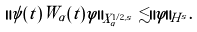<formula> <loc_0><loc_0><loc_500><loc_500>\| \psi ( t ) W _ { \alpha } ( t ) \varphi \| _ { X ^ { 1 / 2 , s } _ { \alpha } } \lesssim \| \varphi \| _ { H ^ { s } } .</formula> 